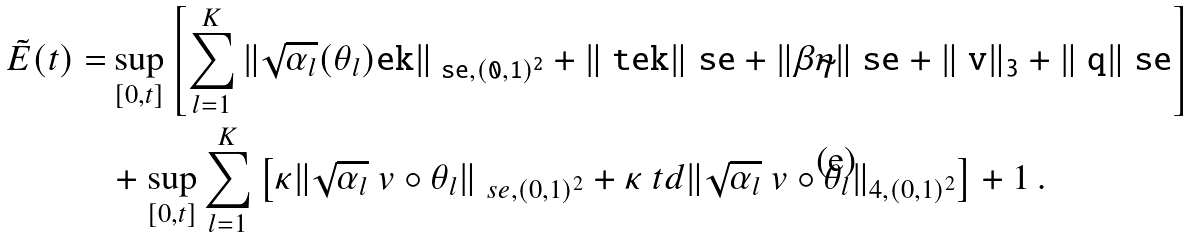Convert formula to latex. <formula><loc_0><loc_0><loc_500><loc_500>\tilde { E } ( t ) = & \sup _ { [ 0 , t ] } \left [ \sum _ { l = 1 } ^ { K } \| \sqrt { \alpha _ { l } } ( \theta _ { l } ) \tt e k \| _ { \ s e , ( 0 , 1 ) ^ { 2 } } + \| \ t e k \| _ { \ } s e + \| \beta \tilde { \eta } \| _ { \ } s e + \| \ v \| _ { 3 } + \| \ q \| _ { \ } s e \right ] \\ & + \sup _ { [ 0 , t ] } \sum _ { l = 1 } ^ { K } \left [ \kappa \| \sqrt { \alpha _ { l } } \ v \circ \theta _ { l } \| _ { \ s e , ( 0 , 1 ) ^ { 2 } } + \kappa ^ { \ } t d \| \sqrt { \alpha _ { l } } \ v \circ \theta _ { l } \| _ { 4 , ( 0 , 1 ) ^ { 2 } } \right ] + 1 \, .</formula> 